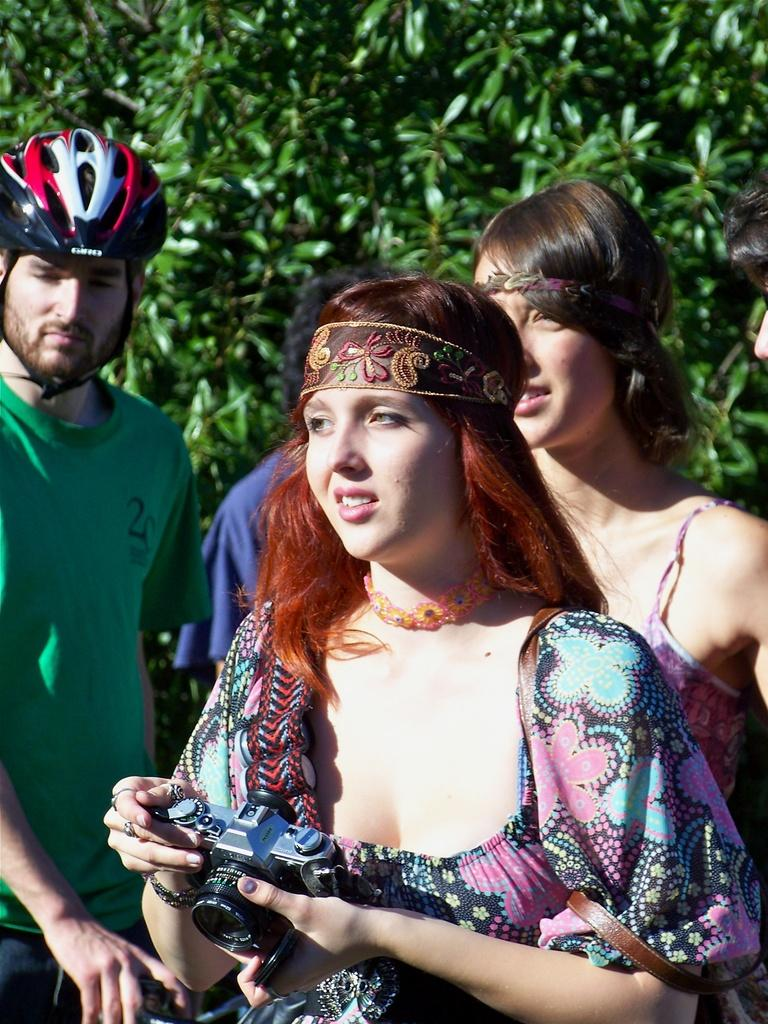What are the people in the image doing? There are people standing in the image. Can you describe what the woman is holding? The woman is holding a camera. What is the man wearing that is not typically worn by everyone? The man is wearing a helmet. What can be seen in the background of the image? There are leaves visible in the background of the image. Can you tell me how many friends are playing baseball in the image? There is no mention of friends or baseball in the image; it only shows people standing, a woman holding a camera, and a man wearing a helmet. 